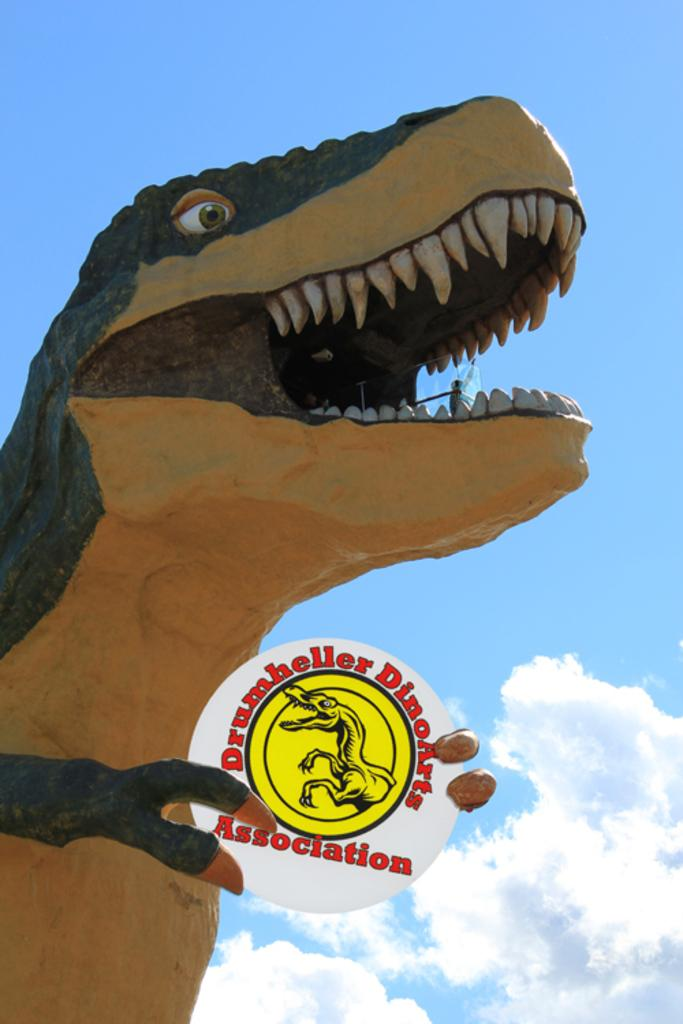What is the main subject of the image? There is a sculpture of a dinosaur in the image. What is the dinosaur sculpture holding? The dinosaur sculpture is holding a board. What can be found on the board? There is text and a picture on the board. What can be seen in the background of the image? The sky is visible in the background of the image. Can you see a match being lit by the dinosaur sculpture in the image? There is no match or any indication of a match being lit in the image. 